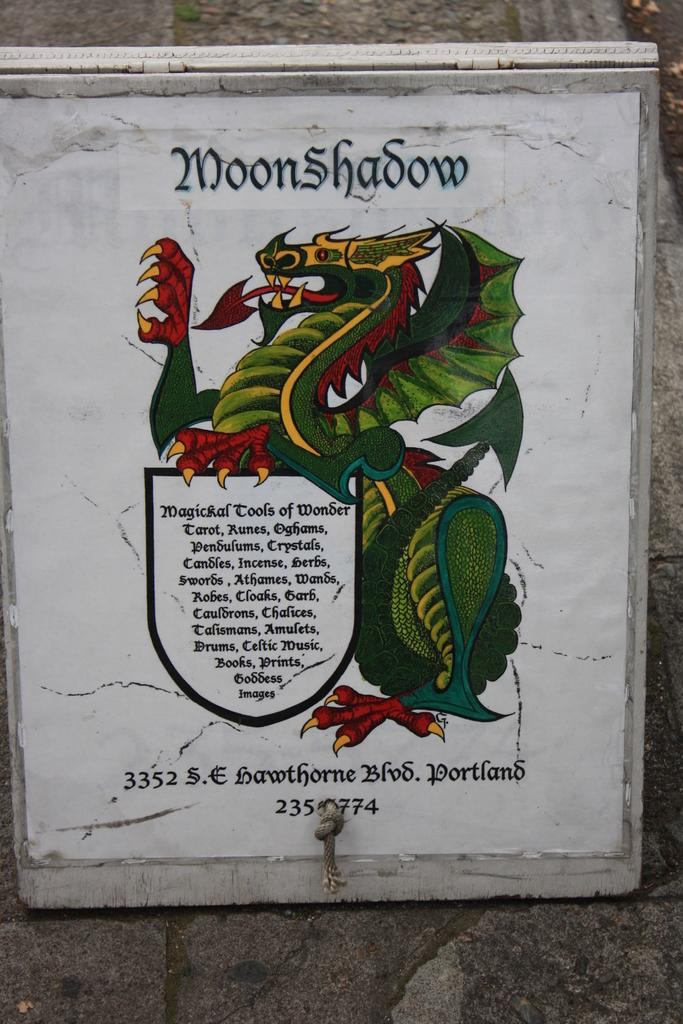Where was the image taken? The image was taken outdoors. What can be seen in the background of the image? There is a wall in the background of the image. What is present in the middle of the image? There is text in the middle of the image. What type of whistle can be heard in the image? There is no whistle present in the image, as it is a still image and cannot produce sound. 